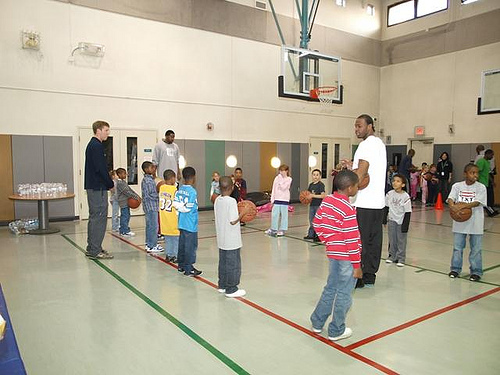<image>
Is the man under the light? No. The man is not positioned under the light. The vertical relationship between these objects is different. Where is the man in relation to the boy? Is it behind the boy? Yes. From this viewpoint, the man is positioned behind the boy, with the boy partially or fully occluding the man. 